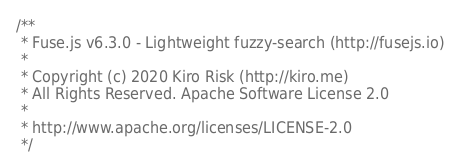Convert code to text. <code><loc_0><loc_0><loc_500><loc_500><_JavaScript_>/**
 * Fuse.js v6.3.0 - Lightweight fuzzy-search (http://fusejs.io)
 *
 * Copyright (c) 2020 Kiro Risk (http://kiro.me)
 * All Rights Reserved. Apache Software License 2.0
 *
 * http://www.apache.org/licenses/LICENSE-2.0
 */</code> 